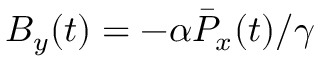<formula> <loc_0><loc_0><loc_500><loc_500>B _ { y } ( t ) = - { \alpha } \bar { P } _ { x } ( t ) / { \gamma }</formula> 